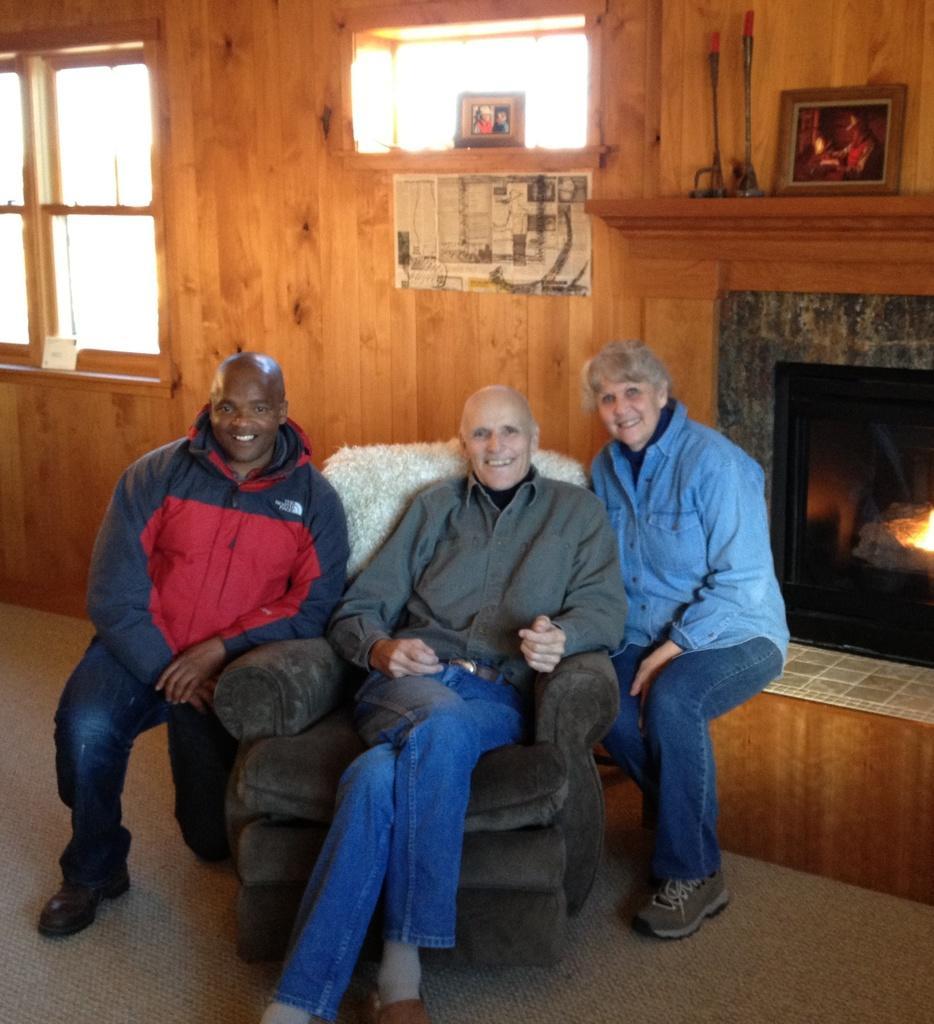Can you describe this image briefly? In the picture I can see three people among them two are sitting. The man on the left side of the image is kneeling down on the floor, the person in the middle is sitting on the chair. On the right side I can see a fireplace. In the background I can see windows, some objects among them some are attached to a wall and some of them on fireplace. 